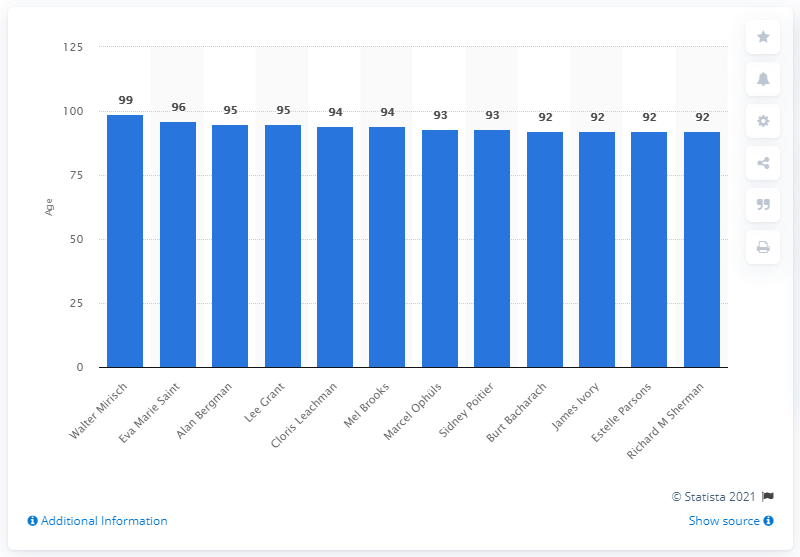Identify some key points in this picture. Walter Mirisch was the oldest living Academy Award winner of all time. 